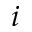Convert formula to latex. <formula><loc_0><loc_0><loc_500><loc_500>i</formula> 